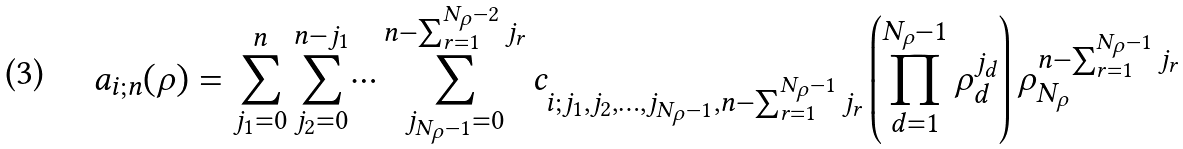Convert formula to latex. <formula><loc_0><loc_0><loc_500><loc_500>a _ { i ; n } ( \rho ) = \sum _ { j _ { 1 } = 0 } ^ { n } \sum _ { j _ { 2 } = 0 } ^ { n - j _ { 1 } } \dots \sum _ { j _ { { N _ { \rho } } - 1 } = 0 } ^ { n - \sum _ { r = 1 } ^ { { N _ { \rho } } - 2 } j _ { r } } c _ { i ; j _ { 1 } , j _ { 2 } , \dots , j _ { { N _ { \rho } } - 1 } , n - \sum _ { r = 1 } ^ { { N _ { \rho } } - 1 } j _ { r } } \left ( \prod _ { d = 1 } ^ { { N _ { \rho } } - 1 } \rho _ { d } ^ { j _ { d } } \right ) \rho _ { N _ { \rho } } ^ { n - \sum _ { r = 1 } ^ { { N _ { \rho } } - 1 } j _ { r } }</formula> 